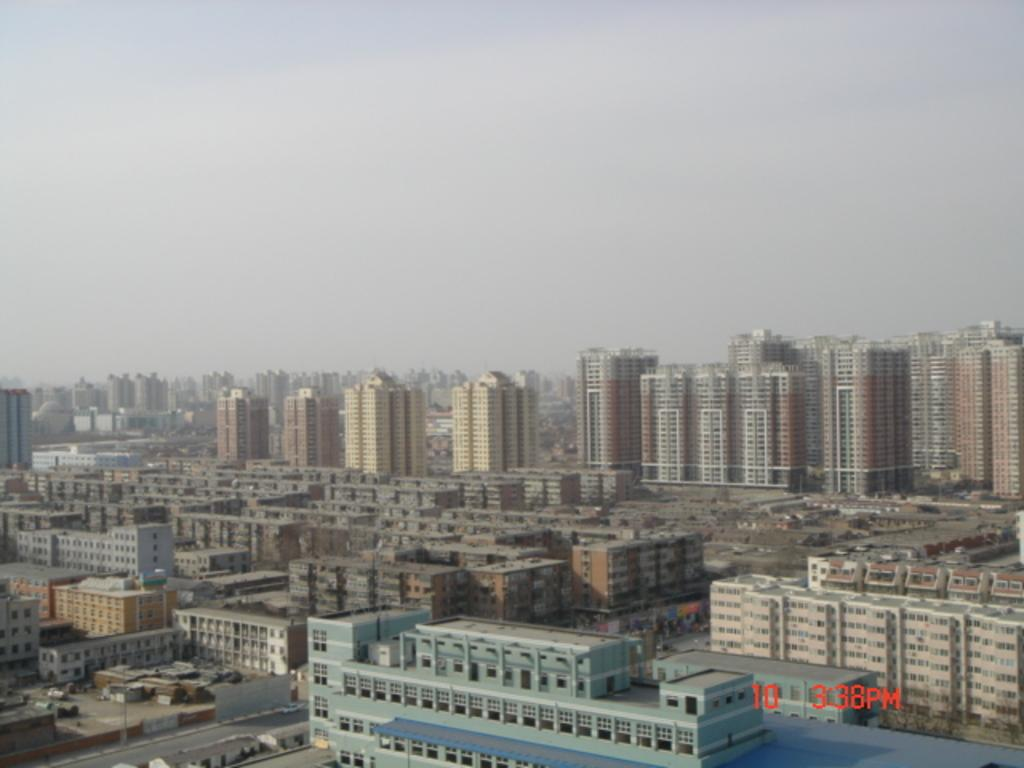What type of view is shown in the image? The image is an outside view. What structures can be seen in the image? There are buildings visible in the image. What type of pathway is present in the image? There is a road in the image. What is moving along the road in the image? Vehicles are present in the image. What is visible at the top of the image? The sky is visible at the top of the image. Can you see a kitten playing with a curtain in the image? There is no kitten or curtain present in the image. What type of face can be seen on the buildings in the image? The buildings in the image do not have faces. 